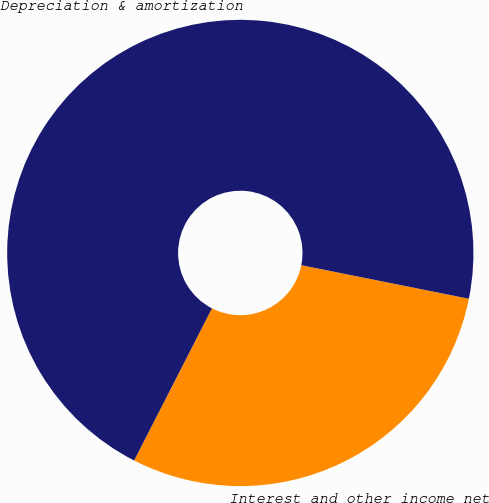Convert chart. <chart><loc_0><loc_0><loc_500><loc_500><pie_chart><fcel>Interest and other income net<fcel>Depreciation & amortization<nl><fcel>29.38%<fcel>70.62%<nl></chart> 